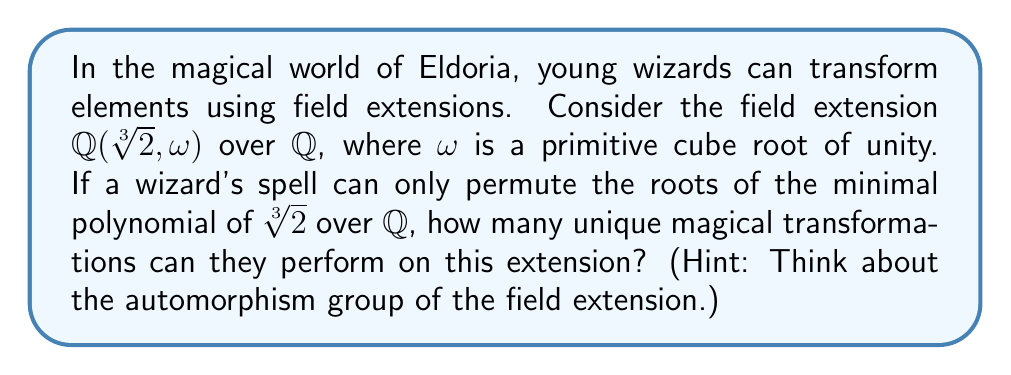Can you solve this math problem? Let's approach this step-by-step:

1) First, we need to understand the field extension $\mathbb{Q}(\sqrt[3]{2}, \omega)$ over $\mathbb{Q}$:
   - $\sqrt[3]{2}$ is a real cube root of 2
   - $\omega$ is a primitive cube root of unity, satisfying $\omega^2 + \omega + 1 = 0$

2) The minimal polynomial of $\sqrt[3]{2}$ over $\mathbb{Q}$ is $x^3 - 2$.

3) The roots of $x^3 - 2$ are $\sqrt[3]{2}$, $\omega\sqrt[3]{2}$, and $\omega^2\sqrt[3]{2}$.

4) The automorphisms of this field extension are determined by how they permute these roots.

5) There are 3! = 6 ways to permute three elements, but we need to consider which of these permutations actually give valid automorphisms.

6) An automorphism must fix $\mathbb{Q}$ and map $\omega$ to either $\omega$ or $\omega^2$ (since these are the only primitive cube roots of unity in the field).

7) This leaves us with only two possibilities for valid automorphisms:
   - The identity automorphism: $\sigma_1(\sqrt[3]{2}) = \sqrt[3]{2}$, $\sigma_1(\omega) = \omega$
   - The automorphism that maps $\sqrt[3]{2}$ to $\omega\sqrt[3]{2}$: $\sigma_2(\sqrt[3]{2}) = \omega\sqrt[3]{2}$, $\sigma_2(\omega) = \omega^2$

8) Therefore, the automorphism group has order 2.

9) In the context of the question, this means the wizard can perform 2 unique magical transformations on this extension.
Answer: 2 